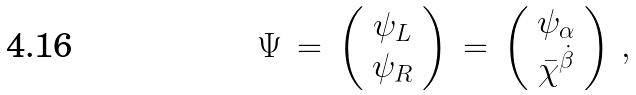<formula> <loc_0><loc_0><loc_500><loc_500>\Psi \, = \, \left ( \begin{array} { c } \psi _ { L } \\ \psi _ { R } \end{array} \right ) \, = \, \left ( \begin{array} { c } \psi _ { \alpha } \\ \bar { \chi } ^ { \dot { \beta } } \end{array} \right ) \, ,</formula> 